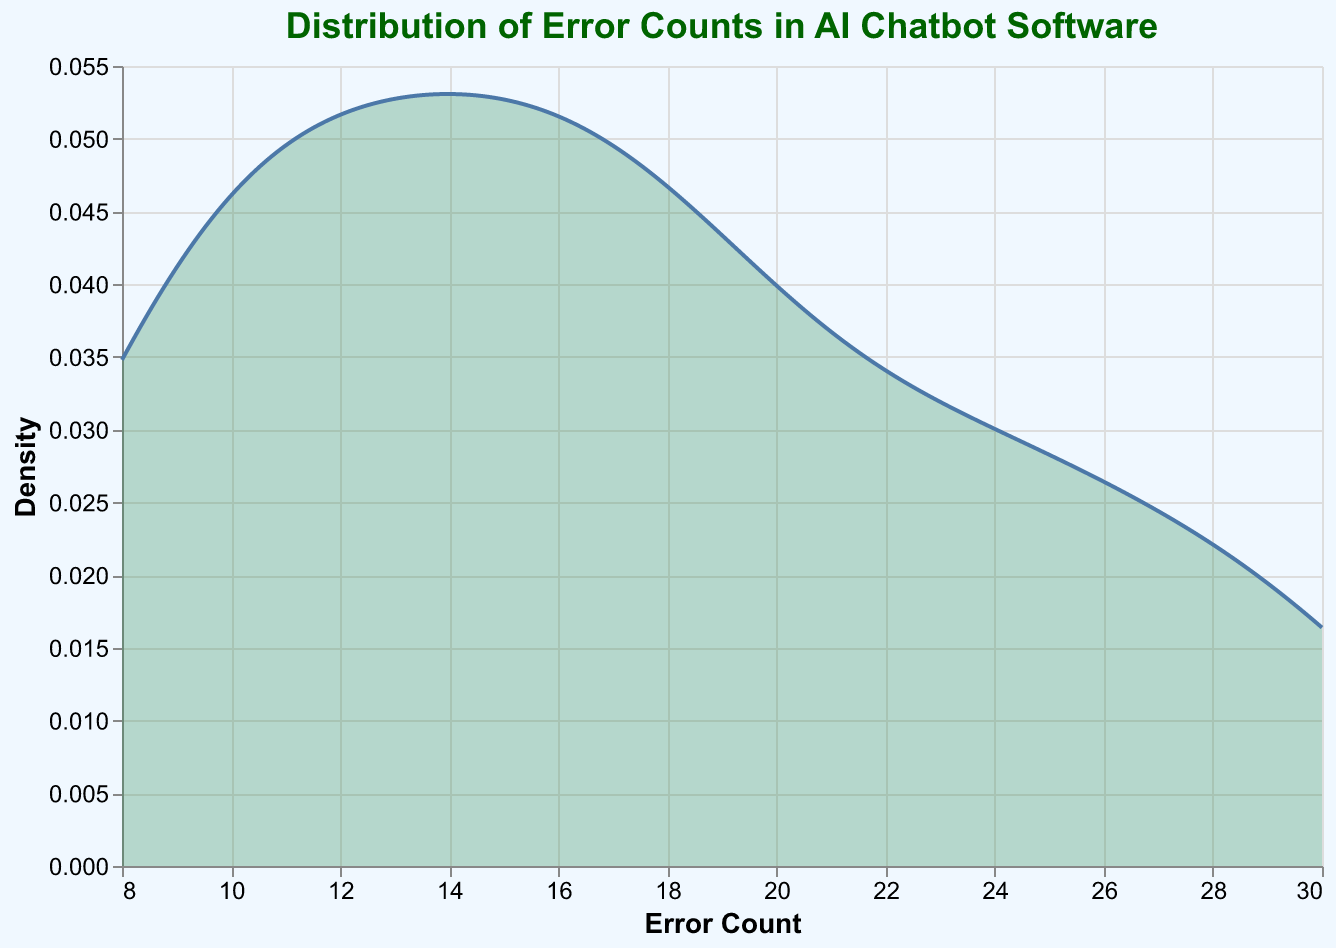What is the title of the density plot? The title of the plot is located at the top and visually informs about the subject of the analysis.
Answer: "Distribution of Error Counts in AI Chatbot Software" Which axis represents the error count? The x-axis is labeled "Error Count," indicating it represents the error count.
Answer: x-axis What is the maximum error count observed in the data? Observing the x-axis range, the maximum error count shown extends up to 30.
Answer: 30 Which color is used to fill the density plot? The filled area of the density plot uses the color seagreen with fill opacity.
Answer: seagreen What is the general trend of error counts in the versions 2.x series over time? The error counts in versions 2.x start high with version 2.0 peaking at 30 but then generally decrease over time to version 2.3 where the error count is around 8.
Answer: Decreasing What is the lowest density value observed in the plot? The y-axis titled "Density" shows the range of density values, with the lowest value observed near zero.
Answer: Near zero Which software version has the highest recorded error count? By examining the dates associated with error counts, version 2.0 has the highest recorded count, observed on 2023-06-15 with an error count of 30.
Answer: Version 2.0 How does the error count distribution change between version 1.x and version 2.x? Comparing the density peaks and spread of error counts, version 1.x has lower error counts with more spread whereas, version 2.x shows higher concentrations but eventually decreases over time.
Answer: More concentrated and higher in 2.x but decreases What is the typical error count range where the density is highest? The highest density indicates the most frequent error counts, seen in the middle lower range of the x-axis, around 10-15 error counts.
Answer: Around 10-15 Is there a version with a consistently decreasing error count trend? Examining the density distributions and specific data points, version 1.3 shows a consistent drop in error counts from 10 to 8.
Answer: Version 1.3 